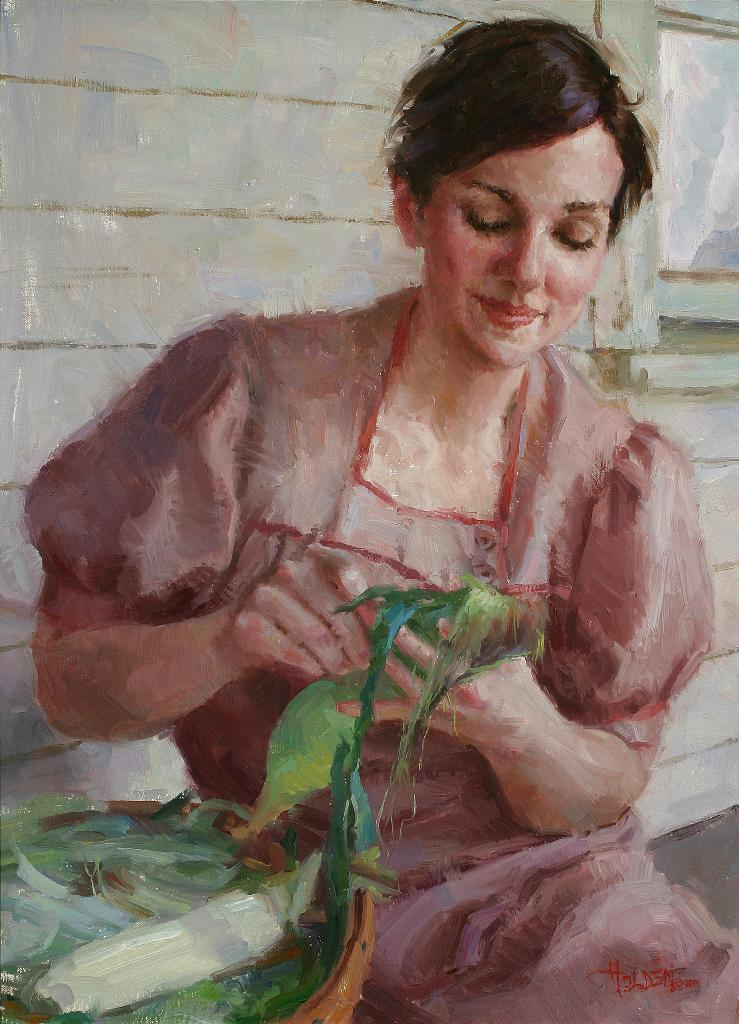What type of artwork is depicted in the image? The image is a painting. Who or what is the main subject of the painting? There is a woman in the painting. What is the woman wearing in the painting? The woman is wearing a dress. What can be seen behind the woman in the painting? There is a wall behind the woman in the painting. Can you see any children playing on the foot in the painting? There is no foot or children playing in the painting; it features a woman standing in front of a wall. 